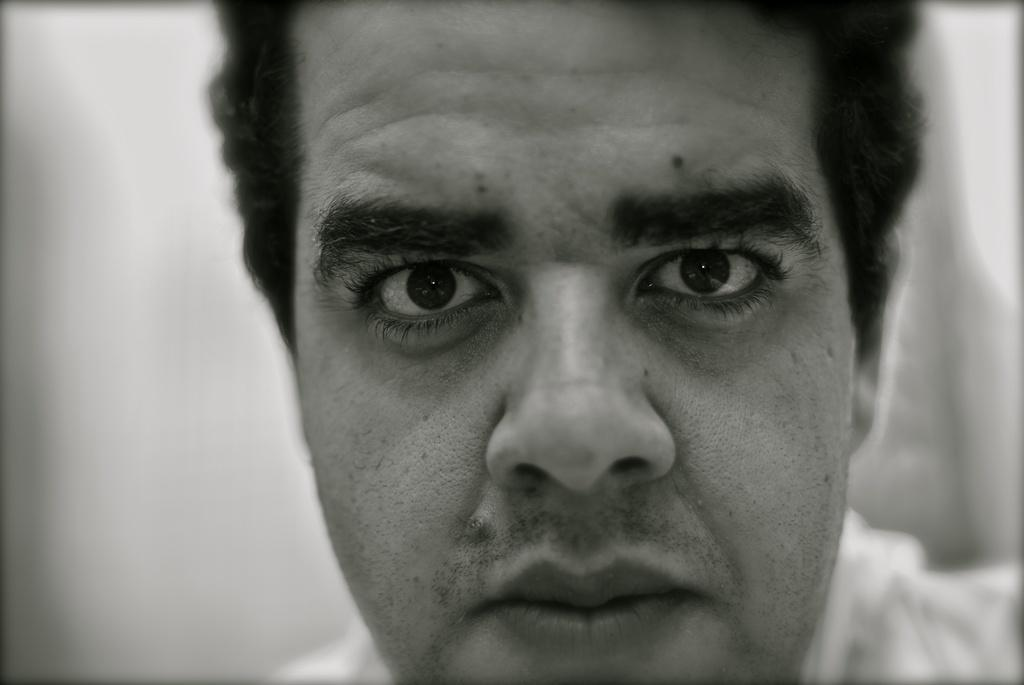What is the main subject of the image? There is a person in the image. Can you describe the background of the image? The background of the image is blurry. What type of iron is being used by the person in the image? There is no iron present in the image; it only features a person with a blurry background. 